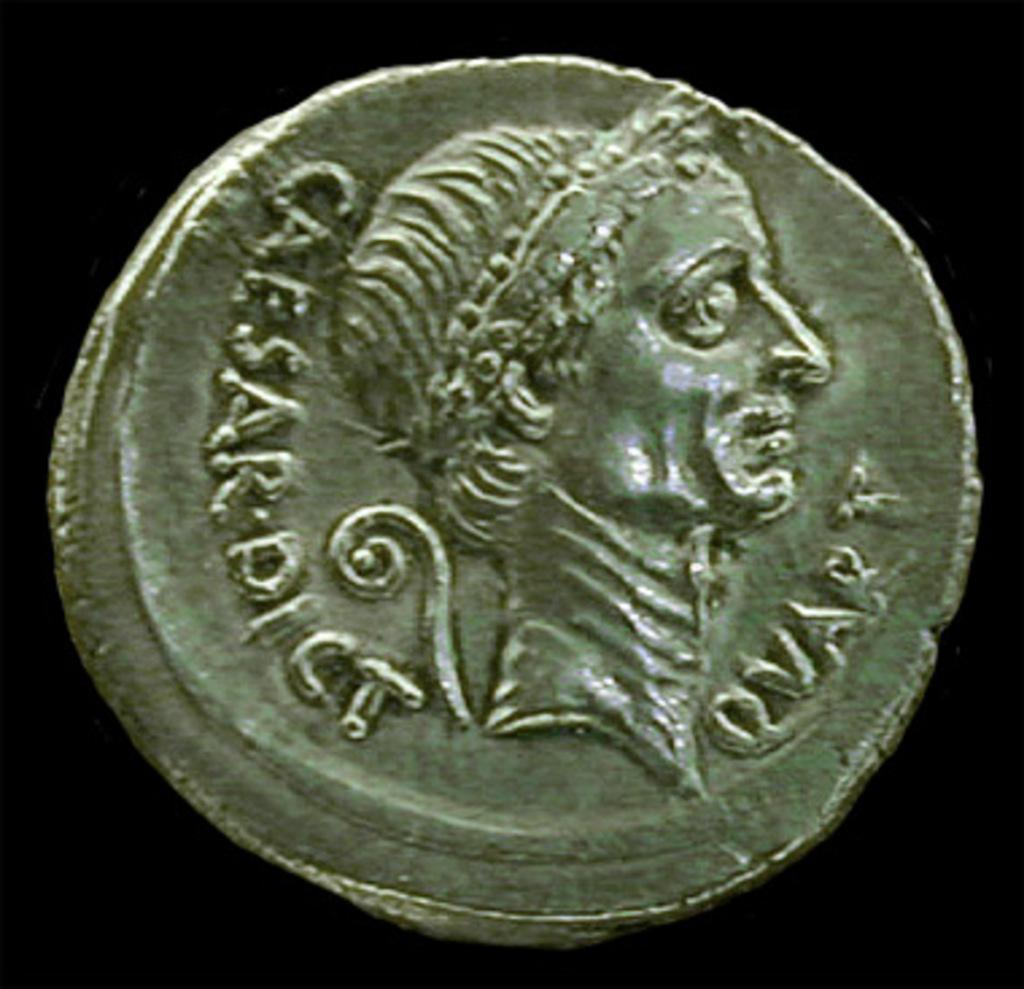<image>
Write a terse but informative summary of the picture. A CAESAR DICT QUART  is stamped into a siver coin with a face in the center of this silver piece. 